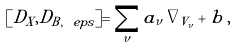Convert formula to latex. <formula><loc_0><loc_0><loc_500><loc_500>[ D _ { X } , D _ { B , \ e p s } ] = \sum _ { \nu } a _ { \nu } \, \nabla _ { V _ { \nu } } + b \, ,</formula> 